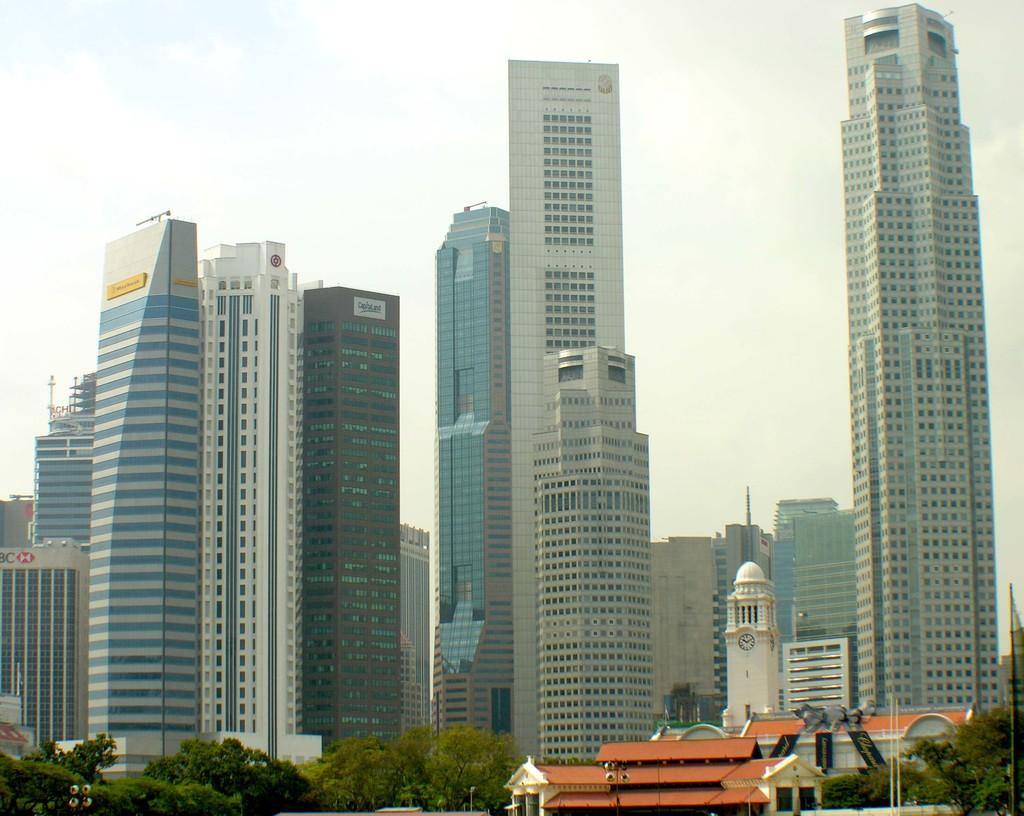What type of structures can be seen in the image? There are buildings in the image. What other natural elements are present in the image? There are trees in the image. What are the tall, thin objects in the image? There are poles in the image. What else can be seen in the image besides buildings, trees, and poles? There are some objects in the image. What is visible in the background of the image? The sky is visible in the background of the image. What type of comfort can be felt from the air in the image? There is no information about the air or comfort in the image, as it only shows buildings, trees, poles, objects, and the sky. What is located on the back of the image? The image does not have a front or back, as it is a two-dimensional representation. 